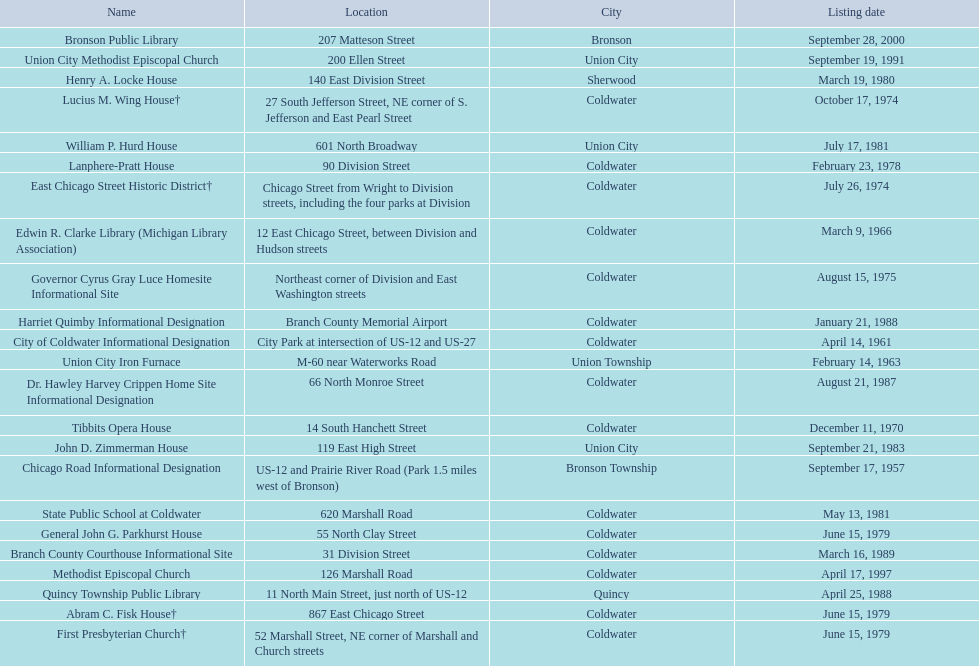Are there any listing dates that happened before 1960? September 17, 1957. What is the name of the site that was listed before 1960? Chicago Road Informational Designation. 